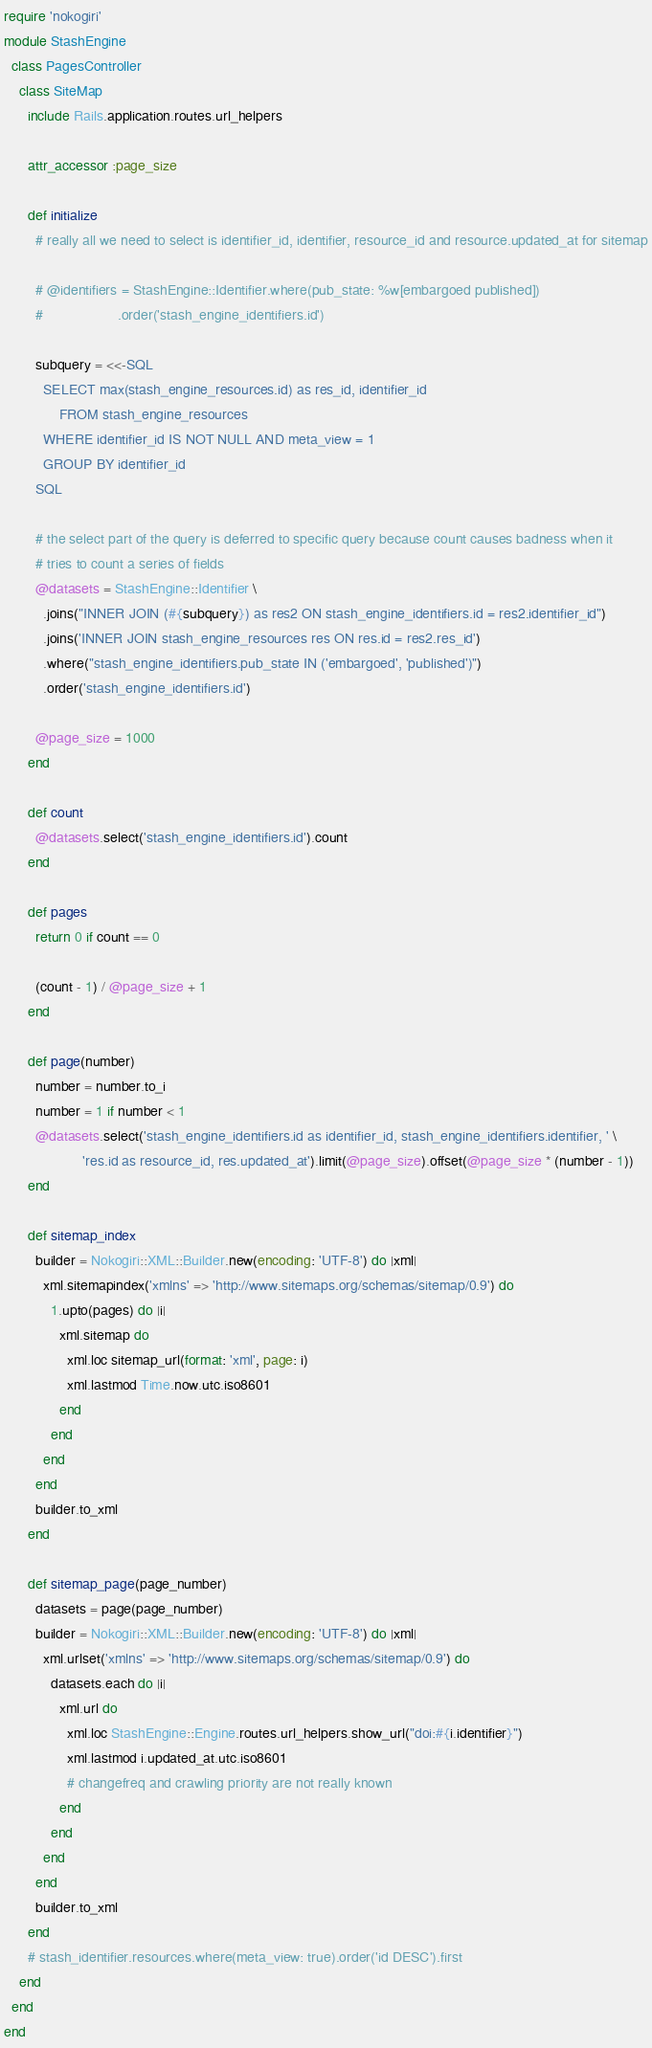<code> <loc_0><loc_0><loc_500><loc_500><_Ruby_>require 'nokogiri'
module StashEngine
  class PagesController
    class SiteMap
      include Rails.application.routes.url_helpers

      attr_accessor :page_size

      def initialize
        # really all we need to select is identifier_id, identifier, resource_id and resource.updated_at for sitemap

        # @identifiers = StashEngine::Identifier.where(pub_state: %w[embargoed published])
        #                   .order('stash_engine_identifiers.id')

        subquery = <<-SQL
          SELECT max(stash_engine_resources.id) as res_id, identifier_id
		      FROM stash_engine_resources
          WHERE identifier_id IS NOT NULL AND meta_view = 1
          GROUP BY identifier_id
        SQL

        # the select part of the query is deferred to specific query because count causes badness when it
        # tries to count a series of fields
        @datasets = StashEngine::Identifier \
          .joins("INNER JOIN (#{subquery}) as res2 ON stash_engine_identifiers.id = res2.identifier_id")
          .joins('INNER JOIN stash_engine_resources res ON res.id = res2.res_id')
          .where("stash_engine_identifiers.pub_state IN ('embargoed', 'published')")
          .order('stash_engine_identifiers.id')

        @page_size = 1000
      end

      def count
        @datasets.select('stash_engine_identifiers.id').count
      end

      def pages
        return 0 if count == 0

        (count - 1) / @page_size + 1
      end

      def page(number)
        number = number.to_i
        number = 1 if number < 1
        @datasets.select('stash_engine_identifiers.id as identifier_id, stash_engine_identifiers.identifier, ' \
                    'res.id as resource_id, res.updated_at').limit(@page_size).offset(@page_size * (number - 1))
      end

      def sitemap_index
        builder = Nokogiri::XML::Builder.new(encoding: 'UTF-8') do |xml|
          xml.sitemapindex('xmlns' => 'http://www.sitemaps.org/schemas/sitemap/0.9') do
            1.upto(pages) do |i|
              xml.sitemap do
                xml.loc sitemap_url(format: 'xml', page: i)
                xml.lastmod Time.now.utc.iso8601
              end
            end
          end
        end
        builder.to_xml
      end

      def sitemap_page(page_number)
        datasets = page(page_number)
        builder = Nokogiri::XML::Builder.new(encoding: 'UTF-8') do |xml|
          xml.urlset('xmlns' => 'http://www.sitemaps.org/schemas/sitemap/0.9') do
            datasets.each do |i|
              xml.url do
                xml.loc StashEngine::Engine.routes.url_helpers.show_url("doi:#{i.identifier}")
                xml.lastmod i.updated_at.utc.iso8601
                # changefreq and crawling priority are not really known
              end
            end
          end
        end
        builder.to_xml
      end
      # stash_identifier.resources.where(meta_view: true).order('id DESC').first
    end
  end
end
</code> 